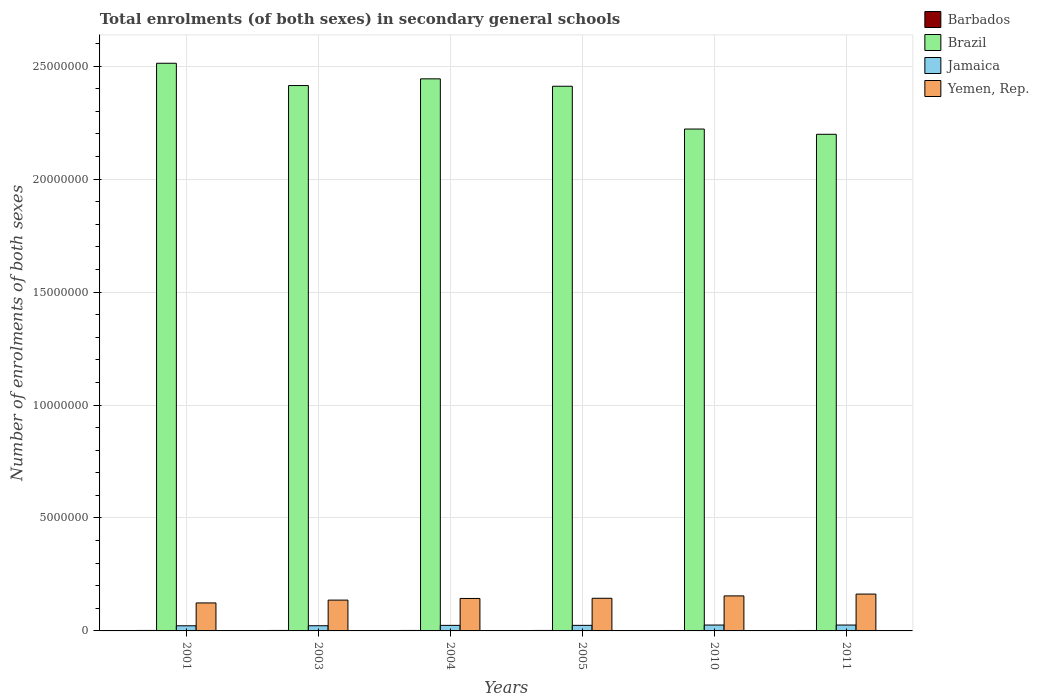How many different coloured bars are there?
Make the answer very short. 4. How many groups of bars are there?
Offer a very short reply. 6. Are the number of bars per tick equal to the number of legend labels?
Offer a terse response. Yes. How many bars are there on the 1st tick from the left?
Your response must be concise. 4. What is the label of the 2nd group of bars from the left?
Your answer should be very brief. 2003. In how many cases, is the number of bars for a given year not equal to the number of legend labels?
Provide a succinct answer. 0. What is the number of enrolments in secondary schools in Brazil in 2001?
Ensure brevity in your answer.  2.51e+07. Across all years, what is the maximum number of enrolments in secondary schools in Yemen, Rep.?
Keep it short and to the point. 1.63e+06. Across all years, what is the minimum number of enrolments in secondary schools in Yemen, Rep.?
Offer a very short reply. 1.24e+06. In which year was the number of enrolments in secondary schools in Yemen, Rep. minimum?
Your answer should be very brief. 2001. What is the total number of enrolments in secondary schools in Brazil in the graph?
Offer a very short reply. 1.42e+08. What is the difference between the number of enrolments in secondary schools in Yemen, Rep. in 2003 and that in 2011?
Your answer should be very brief. -2.67e+05. What is the difference between the number of enrolments in secondary schools in Barbados in 2005 and the number of enrolments in secondary schools in Jamaica in 2001?
Offer a very short reply. -2.06e+05. What is the average number of enrolments in secondary schools in Jamaica per year?
Provide a succinct answer. 2.45e+05. In the year 2010, what is the difference between the number of enrolments in secondary schools in Barbados and number of enrolments in secondary schools in Yemen, Rep.?
Offer a terse response. -1.53e+06. What is the ratio of the number of enrolments in secondary schools in Barbados in 2001 to that in 2003?
Your response must be concise. 1. Is the number of enrolments in secondary schools in Yemen, Rep. in 2001 less than that in 2003?
Provide a succinct answer. Yes. What is the difference between the highest and the second highest number of enrolments in secondary schools in Brazil?
Keep it short and to the point. 6.89e+05. What is the difference between the highest and the lowest number of enrolments in secondary schools in Yemen, Rep.?
Give a very brief answer. 3.92e+05. In how many years, is the number of enrolments in secondary schools in Brazil greater than the average number of enrolments in secondary schools in Brazil taken over all years?
Ensure brevity in your answer.  4. Is the sum of the number of enrolments in secondary schools in Yemen, Rep. in 2003 and 2010 greater than the maximum number of enrolments in secondary schools in Jamaica across all years?
Your answer should be compact. Yes. Is it the case that in every year, the sum of the number of enrolments in secondary schools in Jamaica and number of enrolments in secondary schools in Yemen, Rep. is greater than the sum of number of enrolments in secondary schools in Brazil and number of enrolments in secondary schools in Barbados?
Give a very brief answer. No. What does the 3rd bar from the left in 2003 represents?
Your answer should be compact. Jamaica. What does the 2nd bar from the right in 2003 represents?
Ensure brevity in your answer.  Jamaica. How many bars are there?
Your response must be concise. 24. How many years are there in the graph?
Keep it short and to the point. 6. Are the values on the major ticks of Y-axis written in scientific E-notation?
Provide a short and direct response. No. How are the legend labels stacked?
Offer a terse response. Vertical. What is the title of the graph?
Ensure brevity in your answer.  Total enrolments (of both sexes) in secondary general schools. What is the label or title of the Y-axis?
Your response must be concise. Number of enrolments of both sexes. What is the Number of enrolments of both sexes of Barbados in 2001?
Keep it short and to the point. 2.08e+04. What is the Number of enrolments of both sexes of Brazil in 2001?
Your answer should be compact. 2.51e+07. What is the Number of enrolments of both sexes in Jamaica in 2001?
Provide a short and direct response. 2.27e+05. What is the Number of enrolments of both sexes of Yemen, Rep. in 2001?
Make the answer very short. 1.24e+06. What is the Number of enrolments of both sexes in Barbados in 2003?
Make the answer very short. 2.08e+04. What is the Number of enrolments of both sexes in Brazil in 2003?
Make the answer very short. 2.41e+07. What is the Number of enrolments of both sexes of Jamaica in 2003?
Ensure brevity in your answer.  2.29e+05. What is the Number of enrolments of both sexes in Yemen, Rep. in 2003?
Provide a short and direct response. 1.36e+06. What is the Number of enrolments of both sexes of Barbados in 2004?
Offer a terse response. 2.12e+04. What is the Number of enrolments of both sexes in Brazil in 2004?
Your answer should be compact. 2.44e+07. What is the Number of enrolments of both sexes in Jamaica in 2004?
Make the answer very short. 2.46e+05. What is the Number of enrolments of both sexes in Yemen, Rep. in 2004?
Give a very brief answer. 1.44e+06. What is the Number of enrolments of both sexes of Barbados in 2005?
Make the answer very short. 2.13e+04. What is the Number of enrolments of both sexes in Brazil in 2005?
Offer a terse response. 2.41e+07. What is the Number of enrolments of both sexes of Jamaica in 2005?
Offer a terse response. 2.46e+05. What is the Number of enrolments of both sexes in Yemen, Rep. in 2005?
Your response must be concise. 1.45e+06. What is the Number of enrolments of both sexes of Barbados in 2010?
Give a very brief answer. 1.95e+04. What is the Number of enrolments of both sexes in Brazil in 2010?
Give a very brief answer. 2.22e+07. What is the Number of enrolments of both sexes of Jamaica in 2010?
Ensure brevity in your answer.  2.60e+05. What is the Number of enrolments of both sexes of Yemen, Rep. in 2010?
Give a very brief answer. 1.55e+06. What is the Number of enrolments of both sexes of Barbados in 2011?
Keep it short and to the point. 1.97e+04. What is the Number of enrolments of both sexes of Brazil in 2011?
Make the answer very short. 2.20e+07. What is the Number of enrolments of both sexes of Jamaica in 2011?
Offer a terse response. 2.60e+05. What is the Number of enrolments of both sexes of Yemen, Rep. in 2011?
Your response must be concise. 1.63e+06. Across all years, what is the maximum Number of enrolments of both sexes in Barbados?
Your answer should be very brief. 2.13e+04. Across all years, what is the maximum Number of enrolments of both sexes of Brazil?
Keep it short and to the point. 2.51e+07. Across all years, what is the maximum Number of enrolments of both sexes in Jamaica?
Give a very brief answer. 2.60e+05. Across all years, what is the maximum Number of enrolments of both sexes of Yemen, Rep.?
Make the answer very short. 1.63e+06. Across all years, what is the minimum Number of enrolments of both sexes of Barbados?
Keep it short and to the point. 1.95e+04. Across all years, what is the minimum Number of enrolments of both sexes of Brazil?
Give a very brief answer. 2.20e+07. Across all years, what is the minimum Number of enrolments of both sexes of Jamaica?
Keep it short and to the point. 2.27e+05. Across all years, what is the minimum Number of enrolments of both sexes of Yemen, Rep.?
Your response must be concise. 1.24e+06. What is the total Number of enrolments of both sexes in Barbados in the graph?
Ensure brevity in your answer.  1.23e+05. What is the total Number of enrolments of both sexes of Brazil in the graph?
Provide a short and direct response. 1.42e+08. What is the total Number of enrolments of both sexes in Jamaica in the graph?
Provide a succinct answer. 1.47e+06. What is the total Number of enrolments of both sexes in Yemen, Rep. in the graph?
Make the answer very short. 8.67e+06. What is the difference between the Number of enrolments of both sexes of Barbados in 2001 and that in 2003?
Offer a very short reply. -86. What is the difference between the Number of enrolments of both sexes in Brazil in 2001 and that in 2003?
Give a very brief answer. 9.87e+05. What is the difference between the Number of enrolments of both sexes in Jamaica in 2001 and that in 2003?
Ensure brevity in your answer.  -2120. What is the difference between the Number of enrolments of both sexes in Yemen, Rep. in 2001 and that in 2003?
Offer a very short reply. -1.25e+05. What is the difference between the Number of enrolments of both sexes in Barbados in 2001 and that in 2004?
Make the answer very short. -470. What is the difference between the Number of enrolments of both sexes of Brazil in 2001 and that in 2004?
Provide a short and direct response. 6.89e+05. What is the difference between the Number of enrolments of both sexes in Jamaica in 2001 and that in 2004?
Keep it short and to the point. -1.83e+04. What is the difference between the Number of enrolments of both sexes in Yemen, Rep. in 2001 and that in 2004?
Provide a succinct answer. -1.98e+05. What is the difference between the Number of enrolments of both sexes of Barbados in 2001 and that in 2005?
Make the answer very short. -593. What is the difference between the Number of enrolments of both sexes in Brazil in 2001 and that in 2005?
Provide a short and direct response. 1.02e+06. What is the difference between the Number of enrolments of both sexes of Jamaica in 2001 and that in 2005?
Your answer should be very brief. -1.91e+04. What is the difference between the Number of enrolments of both sexes of Yemen, Rep. in 2001 and that in 2005?
Give a very brief answer. -2.06e+05. What is the difference between the Number of enrolments of both sexes in Barbados in 2001 and that in 2010?
Give a very brief answer. 1255. What is the difference between the Number of enrolments of both sexes in Brazil in 2001 and that in 2010?
Your answer should be very brief. 2.91e+06. What is the difference between the Number of enrolments of both sexes of Jamaica in 2001 and that in 2010?
Offer a very short reply. -3.32e+04. What is the difference between the Number of enrolments of both sexes of Yemen, Rep. in 2001 and that in 2010?
Offer a terse response. -3.12e+05. What is the difference between the Number of enrolments of both sexes of Barbados in 2001 and that in 2011?
Provide a succinct answer. 1056. What is the difference between the Number of enrolments of both sexes in Brazil in 2001 and that in 2011?
Provide a short and direct response. 3.14e+06. What is the difference between the Number of enrolments of both sexes of Jamaica in 2001 and that in 2011?
Offer a very short reply. -3.31e+04. What is the difference between the Number of enrolments of both sexes of Yemen, Rep. in 2001 and that in 2011?
Provide a short and direct response. -3.92e+05. What is the difference between the Number of enrolments of both sexes in Barbados in 2003 and that in 2004?
Your answer should be very brief. -384. What is the difference between the Number of enrolments of both sexes of Brazil in 2003 and that in 2004?
Keep it short and to the point. -2.97e+05. What is the difference between the Number of enrolments of both sexes in Jamaica in 2003 and that in 2004?
Ensure brevity in your answer.  -1.62e+04. What is the difference between the Number of enrolments of both sexes of Yemen, Rep. in 2003 and that in 2004?
Offer a terse response. -7.28e+04. What is the difference between the Number of enrolments of both sexes of Barbados in 2003 and that in 2005?
Give a very brief answer. -507. What is the difference between the Number of enrolments of both sexes of Brazil in 2003 and that in 2005?
Provide a short and direct response. 3.06e+04. What is the difference between the Number of enrolments of both sexes of Jamaica in 2003 and that in 2005?
Give a very brief answer. -1.70e+04. What is the difference between the Number of enrolments of both sexes in Yemen, Rep. in 2003 and that in 2005?
Give a very brief answer. -8.10e+04. What is the difference between the Number of enrolments of both sexes in Barbados in 2003 and that in 2010?
Ensure brevity in your answer.  1341. What is the difference between the Number of enrolments of both sexes of Brazil in 2003 and that in 2010?
Make the answer very short. 1.93e+06. What is the difference between the Number of enrolments of both sexes in Jamaica in 2003 and that in 2010?
Give a very brief answer. -3.10e+04. What is the difference between the Number of enrolments of both sexes of Yemen, Rep. in 2003 and that in 2010?
Make the answer very short. -1.86e+05. What is the difference between the Number of enrolments of both sexes in Barbados in 2003 and that in 2011?
Provide a short and direct response. 1142. What is the difference between the Number of enrolments of both sexes in Brazil in 2003 and that in 2011?
Provide a succinct answer. 2.16e+06. What is the difference between the Number of enrolments of both sexes in Jamaica in 2003 and that in 2011?
Offer a terse response. -3.10e+04. What is the difference between the Number of enrolments of both sexes of Yemen, Rep. in 2003 and that in 2011?
Your answer should be very brief. -2.67e+05. What is the difference between the Number of enrolments of both sexes in Barbados in 2004 and that in 2005?
Provide a succinct answer. -123. What is the difference between the Number of enrolments of both sexes of Brazil in 2004 and that in 2005?
Your answer should be very brief. 3.28e+05. What is the difference between the Number of enrolments of both sexes of Jamaica in 2004 and that in 2005?
Provide a short and direct response. -799. What is the difference between the Number of enrolments of both sexes in Yemen, Rep. in 2004 and that in 2005?
Keep it short and to the point. -8212. What is the difference between the Number of enrolments of both sexes in Barbados in 2004 and that in 2010?
Keep it short and to the point. 1725. What is the difference between the Number of enrolments of both sexes in Brazil in 2004 and that in 2010?
Your answer should be very brief. 2.22e+06. What is the difference between the Number of enrolments of both sexes in Jamaica in 2004 and that in 2010?
Give a very brief answer. -1.48e+04. What is the difference between the Number of enrolments of both sexes in Yemen, Rep. in 2004 and that in 2010?
Provide a succinct answer. -1.14e+05. What is the difference between the Number of enrolments of both sexes of Barbados in 2004 and that in 2011?
Keep it short and to the point. 1526. What is the difference between the Number of enrolments of both sexes in Brazil in 2004 and that in 2011?
Your answer should be very brief. 2.45e+06. What is the difference between the Number of enrolments of both sexes of Jamaica in 2004 and that in 2011?
Offer a very short reply. -1.48e+04. What is the difference between the Number of enrolments of both sexes in Yemen, Rep. in 2004 and that in 2011?
Keep it short and to the point. -1.94e+05. What is the difference between the Number of enrolments of both sexes in Barbados in 2005 and that in 2010?
Keep it short and to the point. 1848. What is the difference between the Number of enrolments of both sexes in Brazil in 2005 and that in 2010?
Your response must be concise. 1.89e+06. What is the difference between the Number of enrolments of both sexes in Jamaica in 2005 and that in 2010?
Give a very brief answer. -1.40e+04. What is the difference between the Number of enrolments of both sexes of Yemen, Rep. in 2005 and that in 2010?
Provide a succinct answer. -1.05e+05. What is the difference between the Number of enrolments of both sexes in Barbados in 2005 and that in 2011?
Your response must be concise. 1649. What is the difference between the Number of enrolments of both sexes in Brazil in 2005 and that in 2011?
Your response must be concise. 2.13e+06. What is the difference between the Number of enrolments of both sexes of Jamaica in 2005 and that in 2011?
Provide a succinct answer. -1.40e+04. What is the difference between the Number of enrolments of both sexes in Yemen, Rep. in 2005 and that in 2011?
Give a very brief answer. -1.86e+05. What is the difference between the Number of enrolments of both sexes of Barbados in 2010 and that in 2011?
Ensure brevity in your answer.  -199. What is the difference between the Number of enrolments of both sexes of Brazil in 2010 and that in 2011?
Offer a very short reply. 2.32e+05. What is the difference between the Number of enrolments of both sexes of Yemen, Rep. in 2010 and that in 2011?
Give a very brief answer. -8.08e+04. What is the difference between the Number of enrolments of both sexes of Barbados in 2001 and the Number of enrolments of both sexes of Brazil in 2003?
Provide a short and direct response. -2.41e+07. What is the difference between the Number of enrolments of both sexes of Barbados in 2001 and the Number of enrolments of both sexes of Jamaica in 2003?
Offer a very short reply. -2.09e+05. What is the difference between the Number of enrolments of both sexes of Barbados in 2001 and the Number of enrolments of both sexes of Yemen, Rep. in 2003?
Offer a terse response. -1.34e+06. What is the difference between the Number of enrolments of both sexes of Brazil in 2001 and the Number of enrolments of both sexes of Jamaica in 2003?
Provide a short and direct response. 2.49e+07. What is the difference between the Number of enrolments of both sexes in Brazil in 2001 and the Number of enrolments of both sexes in Yemen, Rep. in 2003?
Your answer should be compact. 2.38e+07. What is the difference between the Number of enrolments of both sexes of Jamaica in 2001 and the Number of enrolments of both sexes of Yemen, Rep. in 2003?
Offer a terse response. -1.14e+06. What is the difference between the Number of enrolments of both sexes in Barbados in 2001 and the Number of enrolments of both sexes in Brazil in 2004?
Ensure brevity in your answer.  -2.44e+07. What is the difference between the Number of enrolments of both sexes of Barbados in 2001 and the Number of enrolments of both sexes of Jamaica in 2004?
Offer a terse response. -2.25e+05. What is the difference between the Number of enrolments of both sexes of Barbados in 2001 and the Number of enrolments of both sexes of Yemen, Rep. in 2004?
Offer a very short reply. -1.42e+06. What is the difference between the Number of enrolments of both sexes of Brazil in 2001 and the Number of enrolments of both sexes of Jamaica in 2004?
Offer a terse response. 2.49e+07. What is the difference between the Number of enrolments of both sexes of Brazil in 2001 and the Number of enrolments of both sexes of Yemen, Rep. in 2004?
Provide a succinct answer. 2.37e+07. What is the difference between the Number of enrolments of both sexes in Jamaica in 2001 and the Number of enrolments of both sexes in Yemen, Rep. in 2004?
Your answer should be compact. -1.21e+06. What is the difference between the Number of enrolments of both sexes in Barbados in 2001 and the Number of enrolments of both sexes in Brazil in 2005?
Give a very brief answer. -2.41e+07. What is the difference between the Number of enrolments of both sexes of Barbados in 2001 and the Number of enrolments of both sexes of Jamaica in 2005?
Your answer should be compact. -2.26e+05. What is the difference between the Number of enrolments of both sexes of Barbados in 2001 and the Number of enrolments of both sexes of Yemen, Rep. in 2005?
Provide a succinct answer. -1.42e+06. What is the difference between the Number of enrolments of both sexes in Brazil in 2001 and the Number of enrolments of both sexes in Jamaica in 2005?
Provide a succinct answer. 2.49e+07. What is the difference between the Number of enrolments of both sexes in Brazil in 2001 and the Number of enrolments of both sexes in Yemen, Rep. in 2005?
Keep it short and to the point. 2.37e+07. What is the difference between the Number of enrolments of both sexes in Jamaica in 2001 and the Number of enrolments of both sexes in Yemen, Rep. in 2005?
Give a very brief answer. -1.22e+06. What is the difference between the Number of enrolments of both sexes of Barbados in 2001 and the Number of enrolments of both sexes of Brazil in 2010?
Keep it short and to the point. -2.22e+07. What is the difference between the Number of enrolments of both sexes of Barbados in 2001 and the Number of enrolments of both sexes of Jamaica in 2010?
Your answer should be compact. -2.40e+05. What is the difference between the Number of enrolments of both sexes of Barbados in 2001 and the Number of enrolments of both sexes of Yemen, Rep. in 2010?
Provide a short and direct response. -1.53e+06. What is the difference between the Number of enrolments of both sexes of Brazil in 2001 and the Number of enrolments of both sexes of Jamaica in 2010?
Offer a terse response. 2.49e+07. What is the difference between the Number of enrolments of both sexes in Brazil in 2001 and the Number of enrolments of both sexes in Yemen, Rep. in 2010?
Give a very brief answer. 2.36e+07. What is the difference between the Number of enrolments of both sexes of Jamaica in 2001 and the Number of enrolments of both sexes of Yemen, Rep. in 2010?
Provide a short and direct response. -1.32e+06. What is the difference between the Number of enrolments of both sexes of Barbados in 2001 and the Number of enrolments of both sexes of Brazil in 2011?
Ensure brevity in your answer.  -2.20e+07. What is the difference between the Number of enrolments of both sexes in Barbados in 2001 and the Number of enrolments of both sexes in Jamaica in 2011?
Offer a very short reply. -2.40e+05. What is the difference between the Number of enrolments of both sexes of Barbados in 2001 and the Number of enrolments of both sexes of Yemen, Rep. in 2011?
Provide a short and direct response. -1.61e+06. What is the difference between the Number of enrolments of both sexes of Brazil in 2001 and the Number of enrolments of both sexes of Jamaica in 2011?
Your answer should be compact. 2.49e+07. What is the difference between the Number of enrolments of both sexes in Brazil in 2001 and the Number of enrolments of both sexes in Yemen, Rep. in 2011?
Give a very brief answer. 2.35e+07. What is the difference between the Number of enrolments of both sexes of Jamaica in 2001 and the Number of enrolments of both sexes of Yemen, Rep. in 2011?
Offer a terse response. -1.40e+06. What is the difference between the Number of enrolments of both sexes of Barbados in 2003 and the Number of enrolments of both sexes of Brazil in 2004?
Offer a very short reply. -2.44e+07. What is the difference between the Number of enrolments of both sexes in Barbados in 2003 and the Number of enrolments of both sexes in Jamaica in 2004?
Your response must be concise. -2.25e+05. What is the difference between the Number of enrolments of both sexes in Barbados in 2003 and the Number of enrolments of both sexes in Yemen, Rep. in 2004?
Offer a terse response. -1.42e+06. What is the difference between the Number of enrolments of both sexes in Brazil in 2003 and the Number of enrolments of both sexes in Jamaica in 2004?
Make the answer very short. 2.39e+07. What is the difference between the Number of enrolments of both sexes in Brazil in 2003 and the Number of enrolments of both sexes in Yemen, Rep. in 2004?
Ensure brevity in your answer.  2.27e+07. What is the difference between the Number of enrolments of both sexes in Jamaica in 2003 and the Number of enrolments of both sexes in Yemen, Rep. in 2004?
Give a very brief answer. -1.21e+06. What is the difference between the Number of enrolments of both sexes in Barbados in 2003 and the Number of enrolments of both sexes in Brazil in 2005?
Your answer should be compact. -2.41e+07. What is the difference between the Number of enrolments of both sexes of Barbados in 2003 and the Number of enrolments of both sexes of Jamaica in 2005?
Your response must be concise. -2.25e+05. What is the difference between the Number of enrolments of both sexes in Barbados in 2003 and the Number of enrolments of both sexes in Yemen, Rep. in 2005?
Offer a very short reply. -1.42e+06. What is the difference between the Number of enrolments of both sexes in Brazil in 2003 and the Number of enrolments of both sexes in Jamaica in 2005?
Your response must be concise. 2.39e+07. What is the difference between the Number of enrolments of both sexes of Brazil in 2003 and the Number of enrolments of both sexes of Yemen, Rep. in 2005?
Offer a terse response. 2.27e+07. What is the difference between the Number of enrolments of both sexes of Jamaica in 2003 and the Number of enrolments of both sexes of Yemen, Rep. in 2005?
Keep it short and to the point. -1.22e+06. What is the difference between the Number of enrolments of both sexes in Barbados in 2003 and the Number of enrolments of both sexes in Brazil in 2010?
Provide a short and direct response. -2.22e+07. What is the difference between the Number of enrolments of both sexes in Barbados in 2003 and the Number of enrolments of both sexes in Jamaica in 2010?
Your response must be concise. -2.40e+05. What is the difference between the Number of enrolments of both sexes of Barbados in 2003 and the Number of enrolments of both sexes of Yemen, Rep. in 2010?
Give a very brief answer. -1.53e+06. What is the difference between the Number of enrolments of both sexes in Brazil in 2003 and the Number of enrolments of both sexes in Jamaica in 2010?
Offer a very short reply. 2.39e+07. What is the difference between the Number of enrolments of both sexes of Brazil in 2003 and the Number of enrolments of both sexes of Yemen, Rep. in 2010?
Give a very brief answer. 2.26e+07. What is the difference between the Number of enrolments of both sexes of Jamaica in 2003 and the Number of enrolments of both sexes of Yemen, Rep. in 2010?
Give a very brief answer. -1.32e+06. What is the difference between the Number of enrolments of both sexes in Barbados in 2003 and the Number of enrolments of both sexes in Brazil in 2011?
Provide a short and direct response. -2.20e+07. What is the difference between the Number of enrolments of both sexes in Barbados in 2003 and the Number of enrolments of both sexes in Jamaica in 2011?
Keep it short and to the point. -2.39e+05. What is the difference between the Number of enrolments of both sexes in Barbados in 2003 and the Number of enrolments of both sexes in Yemen, Rep. in 2011?
Ensure brevity in your answer.  -1.61e+06. What is the difference between the Number of enrolments of both sexes of Brazil in 2003 and the Number of enrolments of both sexes of Jamaica in 2011?
Provide a short and direct response. 2.39e+07. What is the difference between the Number of enrolments of both sexes of Brazil in 2003 and the Number of enrolments of both sexes of Yemen, Rep. in 2011?
Offer a very short reply. 2.25e+07. What is the difference between the Number of enrolments of both sexes of Jamaica in 2003 and the Number of enrolments of both sexes of Yemen, Rep. in 2011?
Offer a terse response. -1.40e+06. What is the difference between the Number of enrolments of both sexes of Barbados in 2004 and the Number of enrolments of both sexes of Brazil in 2005?
Provide a succinct answer. -2.41e+07. What is the difference between the Number of enrolments of both sexes in Barbados in 2004 and the Number of enrolments of both sexes in Jamaica in 2005?
Keep it short and to the point. -2.25e+05. What is the difference between the Number of enrolments of both sexes in Barbados in 2004 and the Number of enrolments of both sexes in Yemen, Rep. in 2005?
Provide a succinct answer. -1.42e+06. What is the difference between the Number of enrolments of both sexes of Brazil in 2004 and the Number of enrolments of both sexes of Jamaica in 2005?
Offer a terse response. 2.42e+07. What is the difference between the Number of enrolments of both sexes of Brazil in 2004 and the Number of enrolments of both sexes of Yemen, Rep. in 2005?
Ensure brevity in your answer.  2.30e+07. What is the difference between the Number of enrolments of both sexes of Jamaica in 2004 and the Number of enrolments of both sexes of Yemen, Rep. in 2005?
Offer a very short reply. -1.20e+06. What is the difference between the Number of enrolments of both sexes in Barbados in 2004 and the Number of enrolments of both sexes in Brazil in 2010?
Ensure brevity in your answer.  -2.22e+07. What is the difference between the Number of enrolments of both sexes of Barbados in 2004 and the Number of enrolments of both sexes of Jamaica in 2010?
Your answer should be compact. -2.39e+05. What is the difference between the Number of enrolments of both sexes of Barbados in 2004 and the Number of enrolments of both sexes of Yemen, Rep. in 2010?
Provide a succinct answer. -1.53e+06. What is the difference between the Number of enrolments of both sexes in Brazil in 2004 and the Number of enrolments of both sexes in Jamaica in 2010?
Offer a very short reply. 2.42e+07. What is the difference between the Number of enrolments of both sexes in Brazil in 2004 and the Number of enrolments of both sexes in Yemen, Rep. in 2010?
Keep it short and to the point. 2.29e+07. What is the difference between the Number of enrolments of both sexes in Jamaica in 2004 and the Number of enrolments of both sexes in Yemen, Rep. in 2010?
Provide a succinct answer. -1.31e+06. What is the difference between the Number of enrolments of both sexes of Barbados in 2004 and the Number of enrolments of both sexes of Brazil in 2011?
Provide a short and direct response. -2.20e+07. What is the difference between the Number of enrolments of both sexes in Barbados in 2004 and the Number of enrolments of both sexes in Jamaica in 2011?
Your answer should be very brief. -2.39e+05. What is the difference between the Number of enrolments of both sexes in Barbados in 2004 and the Number of enrolments of both sexes in Yemen, Rep. in 2011?
Ensure brevity in your answer.  -1.61e+06. What is the difference between the Number of enrolments of both sexes of Brazil in 2004 and the Number of enrolments of both sexes of Jamaica in 2011?
Your response must be concise. 2.42e+07. What is the difference between the Number of enrolments of both sexes of Brazil in 2004 and the Number of enrolments of both sexes of Yemen, Rep. in 2011?
Ensure brevity in your answer.  2.28e+07. What is the difference between the Number of enrolments of both sexes in Jamaica in 2004 and the Number of enrolments of both sexes in Yemen, Rep. in 2011?
Your answer should be very brief. -1.39e+06. What is the difference between the Number of enrolments of both sexes of Barbados in 2005 and the Number of enrolments of both sexes of Brazil in 2010?
Offer a very short reply. -2.22e+07. What is the difference between the Number of enrolments of both sexes of Barbados in 2005 and the Number of enrolments of both sexes of Jamaica in 2010?
Keep it short and to the point. -2.39e+05. What is the difference between the Number of enrolments of both sexes in Barbados in 2005 and the Number of enrolments of both sexes in Yemen, Rep. in 2010?
Keep it short and to the point. -1.53e+06. What is the difference between the Number of enrolments of both sexes in Brazil in 2005 and the Number of enrolments of both sexes in Jamaica in 2010?
Keep it short and to the point. 2.38e+07. What is the difference between the Number of enrolments of both sexes in Brazil in 2005 and the Number of enrolments of both sexes in Yemen, Rep. in 2010?
Provide a succinct answer. 2.26e+07. What is the difference between the Number of enrolments of both sexes in Jamaica in 2005 and the Number of enrolments of both sexes in Yemen, Rep. in 2010?
Your answer should be very brief. -1.30e+06. What is the difference between the Number of enrolments of both sexes of Barbados in 2005 and the Number of enrolments of both sexes of Brazil in 2011?
Your answer should be compact. -2.20e+07. What is the difference between the Number of enrolments of both sexes of Barbados in 2005 and the Number of enrolments of both sexes of Jamaica in 2011?
Your answer should be very brief. -2.39e+05. What is the difference between the Number of enrolments of both sexes in Barbados in 2005 and the Number of enrolments of both sexes in Yemen, Rep. in 2011?
Keep it short and to the point. -1.61e+06. What is the difference between the Number of enrolments of both sexes of Brazil in 2005 and the Number of enrolments of both sexes of Jamaica in 2011?
Keep it short and to the point. 2.38e+07. What is the difference between the Number of enrolments of both sexes of Brazil in 2005 and the Number of enrolments of both sexes of Yemen, Rep. in 2011?
Ensure brevity in your answer.  2.25e+07. What is the difference between the Number of enrolments of both sexes in Jamaica in 2005 and the Number of enrolments of both sexes in Yemen, Rep. in 2011?
Give a very brief answer. -1.39e+06. What is the difference between the Number of enrolments of both sexes in Barbados in 2010 and the Number of enrolments of both sexes in Brazil in 2011?
Keep it short and to the point. -2.20e+07. What is the difference between the Number of enrolments of both sexes of Barbados in 2010 and the Number of enrolments of both sexes of Jamaica in 2011?
Your response must be concise. -2.41e+05. What is the difference between the Number of enrolments of both sexes of Barbados in 2010 and the Number of enrolments of both sexes of Yemen, Rep. in 2011?
Provide a succinct answer. -1.61e+06. What is the difference between the Number of enrolments of both sexes of Brazil in 2010 and the Number of enrolments of both sexes of Jamaica in 2011?
Offer a terse response. 2.20e+07. What is the difference between the Number of enrolments of both sexes in Brazil in 2010 and the Number of enrolments of both sexes in Yemen, Rep. in 2011?
Your response must be concise. 2.06e+07. What is the difference between the Number of enrolments of both sexes of Jamaica in 2010 and the Number of enrolments of both sexes of Yemen, Rep. in 2011?
Make the answer very short. -1.37e+06. What is the average Number of enrolments of both sexes of Barbados per year?
Ensure brevity in your answer.  2.06e+04. What is the average Number of enrolments of both sexes in Brazil per year?
Give a very brief answer. 2.37e+07. What is the average Number of enrolments of both sexes in Jamaica per year?
Provide a succinct answer. 2.45e+05. What is the average Number of enrolments of both sexes in Yemen, Rep. per year?
Provide a succinct answer. 1.44e+06. In the year 2001, what is the difference between the Number of enrolments of both sexes of Barbados and Number of enrolments of both sexes of Brazil?
Your response must be concise. -2.51e+07. In the year 2001, what is the difference between the Number of enrolments of both sexes in Barbados and Number of enrolments of both sexes in Jamaica?
Make the answer very short. -2.06e+05. In the year 2001, what is the difference between the Number of enrolments of both sexes of Barbados and Number of enrolments of both sexes of Yemen, Rep.?
Give a very brief answer. -1.22e+06. In the year 2001, what is the difference between the Number of enrolments of both sexes in Brazil and Number of enrolments of both sexes in Jamaica?
Your answer should be compact. 2.49e+07. In the year 2001, what is the difference between the Number of enrolments of both sexes in Brazil and Number of enrolments of both sexes in Yemen, Rep.?
Make the answer very short. 2.39e+07. In the year 2001, what is the difference between the Number of enrolments of both sexes in Jamaica and Number of enrolments of both sexes in Yemen, Rep.?
Provide a short and direct response. -1.01e+06. In the year 2003, what is the difference between the Number of enrolments of both sexes of Barbados and Number of enrolments of both sexes of Brazil?
Provide a succinct answer. -2.41e+07. In the year 2003, what is the difference between the Number of enrolments of both sexes of Barbados and Number of enrolments of both sexes of Jamaica?
Ensure brevity in your answer.  -2.08e+05. In the year 2003, what is the difference between the Number of enrolments of both sexes of Barbados and Number of enrolments of both sexes of Yemen, Rep.?
Your answer should be very brief. -1.34e+06. In the year 2003, what is the difference between the Number of enrolments of both sexes in Brazil and Number of enrolments of both sexes in Jamaica?
Your answer should be very brief. 2.39e+07. In the year 2003, what is the difference between the Number of enrolments of both sexes of Brazil and Number of enrolments of both sexes of Yemen, Rep.?
Your answer should be compact. 2.28e+07. In the year 2003, what is the difference between the Number of enrolments of both sexes in Jamaica and Number of enrolments of both sexes in Yemen, Rep.?
Make the answer very short. -1.13e+06. In the year 2004, what is the difference between the Number of enrolments of both sexes in Barbados and Number of enrolments of both sexes in Brazil?
Give a very brief answer. -2.44e+07. In the year 2004, what is the difference between the Number of enrolments of both sexes in Barbados and Number of enrolments of both sexes in Jamaica?
Provide a succinct answer. -2.24e+05. In the year 2004, what is the difference between the Number of enrolments of both sexes in Barbados and Number of enrolments of both sexes in Yemen, Rep.?
Provide a short and direct response. -1.42e+06. In the year 2004, what is the difference between the Number of enrolments of both sexes in Brazil and Number of enrolments of both sexes in Jamaica?
Make the answer very short. 2.42e+07. In the year 2004, what is the difference between the Number of enrolments of both sexes of Brazil and Number of enrolments of both sexes of Yemen, Rep.?
Ensure brevity in your answer.  2.30e+07. In the year 2004, what is the difference between the Number of enrolments of both sexes in Jamaica and Number of enrolments of both sexes in Yemen, Rep.?
Make the answer very short. -1.19e+06. In the year 2005, what is the difference between the Number of enrolments of both sexes in Barbados and Number of enrolments of both sexes in Brazil?
Ensure brevity in your answer.  -2.41e+07. In the year 2005, what is the difference between the Number of enrolments of both sexes in Barbados and Number of enrolments of both sexes in Jamaica?
Provide a short and direct response. -2.25e+05. In the year 2005, what is the difference between the Number of enrolments of both sexes of Barbados and Number of enrolments of both sexes of Yemen, Rep.?
Provide a succinct answer. -1.42e+06. In the year 2005, what is the difference between the Number of enrolments of both sexes of Brazil and Number of enrolments of both sexes of Jamaica?
Offer a terse response. 2.39e+07. In the year 2005, what is the difference between the Number of enrolments of both sexes of Brazil and Number of enrolments of both sexes of Yemen, Rep.?
Ensure brevity in your answer.  2.27e+07. In the year 2005, what is the difference between the Number of enrolments of both sexes in Jamaica and Number of enrolments of both sexes in Yemen, Rep.?
Keep it short and to the point. -1.20e+06. In the year 2010, what is the difference between the Number of enrolments of both sexes in Barbados and Number of enrolments of both sexes in Brazil?
Provide a succinct answer. -2.22e+07. In the year 2010, what is the difference between the Number of enrolments of both sexes of Barbados and Number of enrolments of both sexes of Jamaica?
Provide a succinct answer. -2.41e+05. In the year 2010, what is the difference between the Number of enrolments of both sexes of Barbados and Number of enrolments of both sexes of Yemen, Rep.?
Make the answer very short. -1.53e+06. In the year 2010, what is the difference between the Number of enrolments of both sexes of Brazil and Number of enrolments of both sexes of Jamaica?
Your answer should be compact. 2.20e+07. In the year 2010, what is the difference between the Number of enrolments of both sexes of Brazil and Number of enrolments of both sexes of Yemen, Rep.?
Your answer should be very brief. 2.07e+07. In the year 2010, what is the difference between the Number of enrolments of both sexes of Jamaica and Number of enrolments of both sexes of Yemen, Rep.?
Provide a short and direct response. -1.29e+06. In the year 2011, what is the difference between the Number of enrolments of both sexes in Barbados and Number of enrolments of both sexes in Brazil?
Your response must be concise. -2.20e+07. In the year 2011, what is the difference between the Number of enrolments of both sexes of Barbados and Number of enrolments of both sexes of Jamaica?
Give a very brief answer. -2.41e+05. In the year 2011, what is the difference between the Number of enrolments of both sexes in Barbados and Number of enrolments of both sexes in Yemen, Rep.?
Offer a very short reply. -1.61e+06. In the year 2011, what is the difference between the Number of enrolments of both sexes of Brazil and Number of enrolments of both sexes of Jamaica?
Provide a short and direct response. 2.17e+07. In the year 2011, what is the difference between the Number of enrolments of both sexes in Brazil and Number of enrolments of both sexes in Yemen, Rep.?
Your answer should be compact. 2.04e+07. In the year 2011, what is the difference between the Number of enrolments of both sexes in Jamaica and Number of enrolments of both sexes in Yemen, Rep.?
Provide a succinct answer. -1.37e+06. What is the ratio of the Number of enrolments of both sexes in Brazil in 2001 to that in 2003?
Make the answer very short. 1.04. What is the ratio of the Number of enrolments of both sexes in Jamaica in 2001 to that in 2003?
Provide a short and direct response. 0.99. What is the ratio of the Number of enrolments of both sexes in Yemen, Rep. in 2001 to that in 2003?
Give a very brief answer. 0.91. What is the ratio of the Number of enrolments of both sexes in Barbados in 2001 to that in 2004?
Your answer should be very brief. 0.98. What is the ratio of the Number of enrolments of both sexes in Brazil in 2001 to that in 2004?
Make the answer very short. 1.03. What is the ratio of the Number of enrolments of both sexes of Jamaica in 2001 to that in 2004?
Offer a terse response. 0.93. What is the ratio of the Number of enrolments of both sexes of Yemen, Rep. in 2001 to that in 2004?
Your answer should be very brief. 0.86. What is the ratio of the Number of enrolments of both sexes in Barbados in 2001 to that in 2005?
Your response must be concise. 0.97. What is the ratio of the Number of enrolments of both sexes in Brazil in 2001 to that in 2005?
Offer a very short reply. 1.04. What is the ratio of the Number of enrolments of both sexes in Jamaica in 2001 to that in 2005?
Offer a very short reply. 0.92. What is the ratio of the Number of enrolments of both sexes of Yemen, Rep. in 2001 to that in 2005?
Give a very brief answer. 0.86. What is the ratio of the Number of enrolments of both sexes of Barbados in 2001 to that in 2010?
Give a very brief answer. 1.06. What is the ratio of the Number of enrolments of both sexes of Brazil in 2001 to that in 2010?
Your response must be concise. 1.13. What is the ratio of the Number of enrolments of both sexes in Jamaica in 2001 to that in 2010?
Provide a succinct answer. 0.87. What is the ratio of the Number of enrolments of both sexes of Yemen, Rep. in 2001 to that in 2010?
Provide a short and direct response. 0.8. What is the ratio of the Number of enrolments of both sexes of Barbados in 2001 to that in 2011?
Give a very brief answer. 1.05. What is the ratio of the Number of enrolments of both sexes of Brazil in 2001 to that in 2011?
Provide a short and direct response. 1.14. What is the ratio of the Number of enrolments of both sexes in Jamaica in 2001 to that in 2011?
Offer a terse response. 0.87. What is the ratio of the Number of enrolments of both sexes of Yemen, Rep. in 2001 to that in 2011?
Offer a terse response. 0.76. What is the ratio of the Number of enrolments of both sexes in Barbados in 2003 to that in 2004?
Offer a very short reply. 0.98. What is the ratio of the Number of enrolments of both sexes of Brazil in 2003 to that in 2004?
Offer a terse response. 0.99. What is the ratio of the Number of enrolments of both sexes in Jamaica in 2003 to that in 2004?
Your answer should be compact. 0.93. What is the ratio of the Number of enrolments of both sexes of Yemen, Rep. in 2003 to that in 2004?
Provide a short and direct response. 0.95. What is the ratio of the Number of enrolments of both sexes in Barbados in 2003 to that in 2005?
Make the answer very short. 0.98. What is the ratio of the Number of enrolments of both sexes of Brazil in 2003 to that in 2005?
Provide a short and direct response. 1. What is the ratio of the Number of enrolments of both sexes of Yemen, Rep. in 2003 to that in 2005?
Provide a short and direct response. 0.94. What is the ratio of the Number of enrolments of both sexes in Barbados in 2003 to that in 2010?
Offer a terse response. 1.07. What is the ratio of the Number of enrolments of both sexes in Brazil in 2003 to that in 2010?
Keep it short and to the point. 1.09. What is the ratio of the Number of enrolments of both sexes of Jamaica in 2003 to that in 2010?
Make the answer very short. 0.88. What is the ratio of the Number of enrolments of both sexes in Yemen, Rep. in 2003 to that in 2010?
Provide a short and direct response. 0.88. What is the ratio of the Number of enrolments of both sexes of Barbados in 2003 to that in 2011?
Make the answer very short. 1.06. What is the ratio of the Number of enrolments of both sexes in Brazil in 2003 to that in 2011?
Offer a terse response. 1.1. What is the ratio of the Number of enrolments of both sexes in Jamaica in 2003 to that in 2011?
Your response must be concise. 0.88. What is the ratio of the Number of enrolments of both sexes in Yemen, Rep. in 2003 to that in 2011?
Provide a short and direct response. 0.84. What is the ratio of the Number of enrolments of both sexes in Brazil in 2004 to that in 2005?
Offer a terse response. 1.01. What is the ratio of the Number of enrolments of both sexes in Barbados in 2004 to that in 2010?
Offer a very short reply. 1.09. What is the ratio of the Number of enrolments of both sexes of Brazil in 2004 to that in 2010?
Offer a very short reply. 1.1. What is the ratio of the Number of enrolments of both sexes of Jamaica in 2004 to that in 2010?
Provide a short and direct response. 0.94. What is the ratio of the Number of enrolments of both sexes in Yemen, Rep. in 2004 to that in 2010?
Make the answer very short. 0.93. What is the ratio of the Number of enrolments of both sexes in Barbados in 2004 to that in 2011?
Offer a terse response. 1.08. What is the ratio of the Number of enrolments of both sexes of Brazil in 2004 to that in 2011?
Make the answer very short. 1.11. What is the ratio of the Number of enrolments of both sexes of Jamaica in 2004 to that in 2011?
Make the answer very short. 0.94. What is the ratio of the Number of enrolments of both sexes of Yemen, Rep. in 2004 to that in 2011?
Offer a very short reply. 0.88. What is the ratio of the Number of enrolments of both sexes in Barbados in 2005 to that in 2010?
Offer a terse response. 1.09. What is the ratio of the Number of enrolments of both sexes of Brazil in 2005 to that in 2010?
Your answer should be very brief. 1.09. What is the ratio of the Number of enrolments of both sexes of Jamaica in 2005 to that in 2010?
Provide a short and direct response. 0.95. What is the ratio of the Number of enrolments of both sexes of Yemen, Rep. in 2005 to that in 2010?
Your answer should be compact. 0.93. What is the ratio of the Number of enrolments of both sexes of Barbados in 2005 to that in 2011?
Ensure brevity in your answer.  1.08. What is the ratio of the Number of enrolments of both sexes in Brazil in 2005 to that in 2011?
Keep it short and to the point. 1.1. What is the ratio of the Number of enrolments of both sexes of Jamaica in 2005 to that in 2011?
Your response must be concise. 0.95. What is the ratio of the Number of enrolments of both sexes of Yemen, Rep. in 2005 to that in 2011?
Make the answer very short. 0.89. What is the ratio of the Number of enrolments of both sexes in Barbados in 2010 to that in 2011?
Keep it short and to the point. 0.99. What is the ratio of the Number of enrolments of both sexes in Brazil in 2010 to that in 2011?
Provide a short and direct response. 1.01. What is the ratio of the Number of enrolments of both sexes of Yemen, Rep. in 2010 to that in 2011?
Your answer should be compact. 0.95. What is the difference between the highest and the second highest Number of enrolments of both sexes of Barbados?
Make the answer very short. 123. What is the difference between the highest and the second highest Number of enrolments of both sexes in Brazil?
Give a very brief answer. 6.89e+05. What is the difference between the highest and the second highest Number of enrolments of both sexes of Yemen, Rep.?
Ensure brevity in your answer.  8.08e+04. What is the difference between the highest and the lowest Number of enrolments of both sexes of Barbados?
Offer a terse response. 1848. What is the difference between the highest and the lowest Number of enrolments of both sexes in Brazil?
Ensure brevity in your answer.  3.14e+06. What is the difference between the highest and the lowest Number of enrolments of both sexes of Jamaica?
Offer a terse response. 3.32e+04. What is the difference between the highest and the lowest Number of enrolments of both sexes of Yemen, Rep.?
Offer a very short reply. 3.92e+05. 